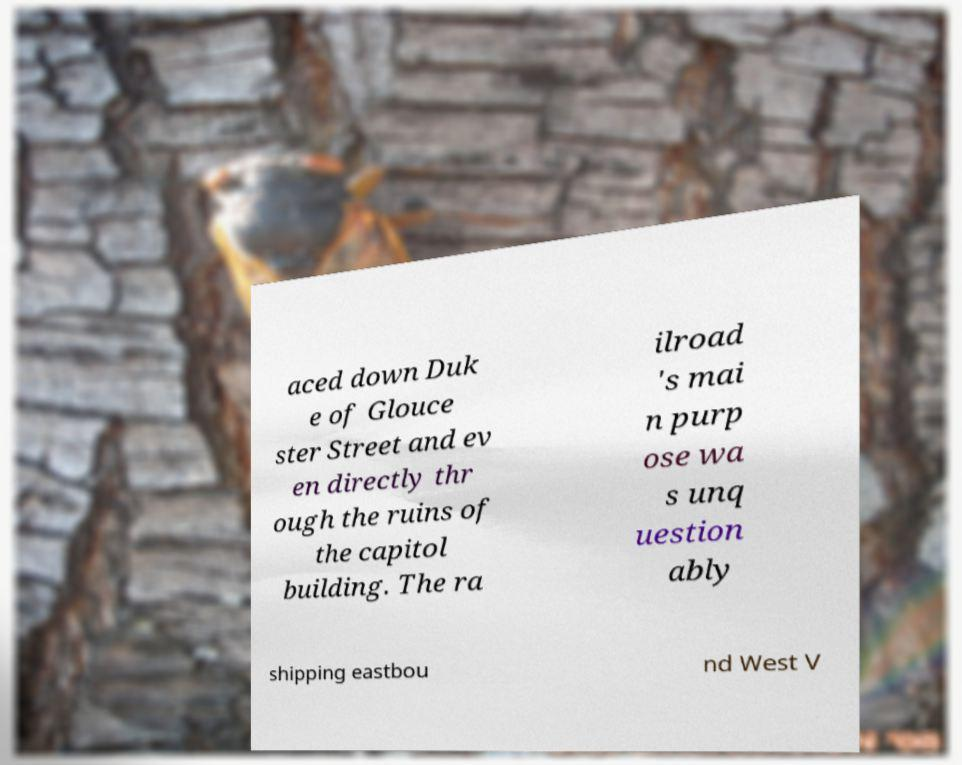Please identify and transcribe the text found in this image. aced down Duk e of Glouce ster Street and ev en directly thr ough the ruins of the capitol building. The ra ilroad 's mai n purp ose wa s unq uestion ably shipping eastbou nd West V 